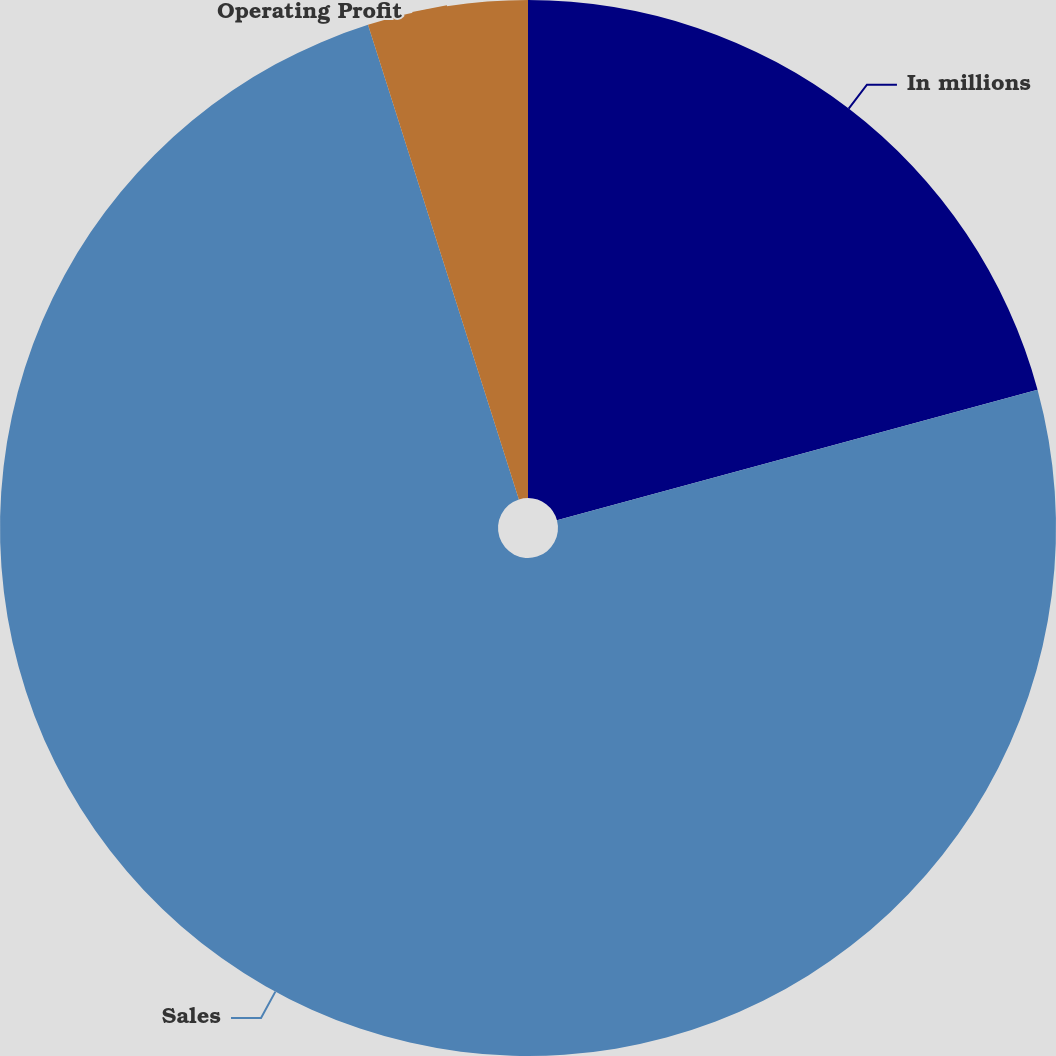Convert chart. <chart><loc_0><loc_0><loc_500><loc_500><pie_chart><fcel>In millions<fcel>Sales<fcel>Operating Profit<nl><fcel>20.78%<fcel>74.32%<fcel>4.9%<nl></chart> 